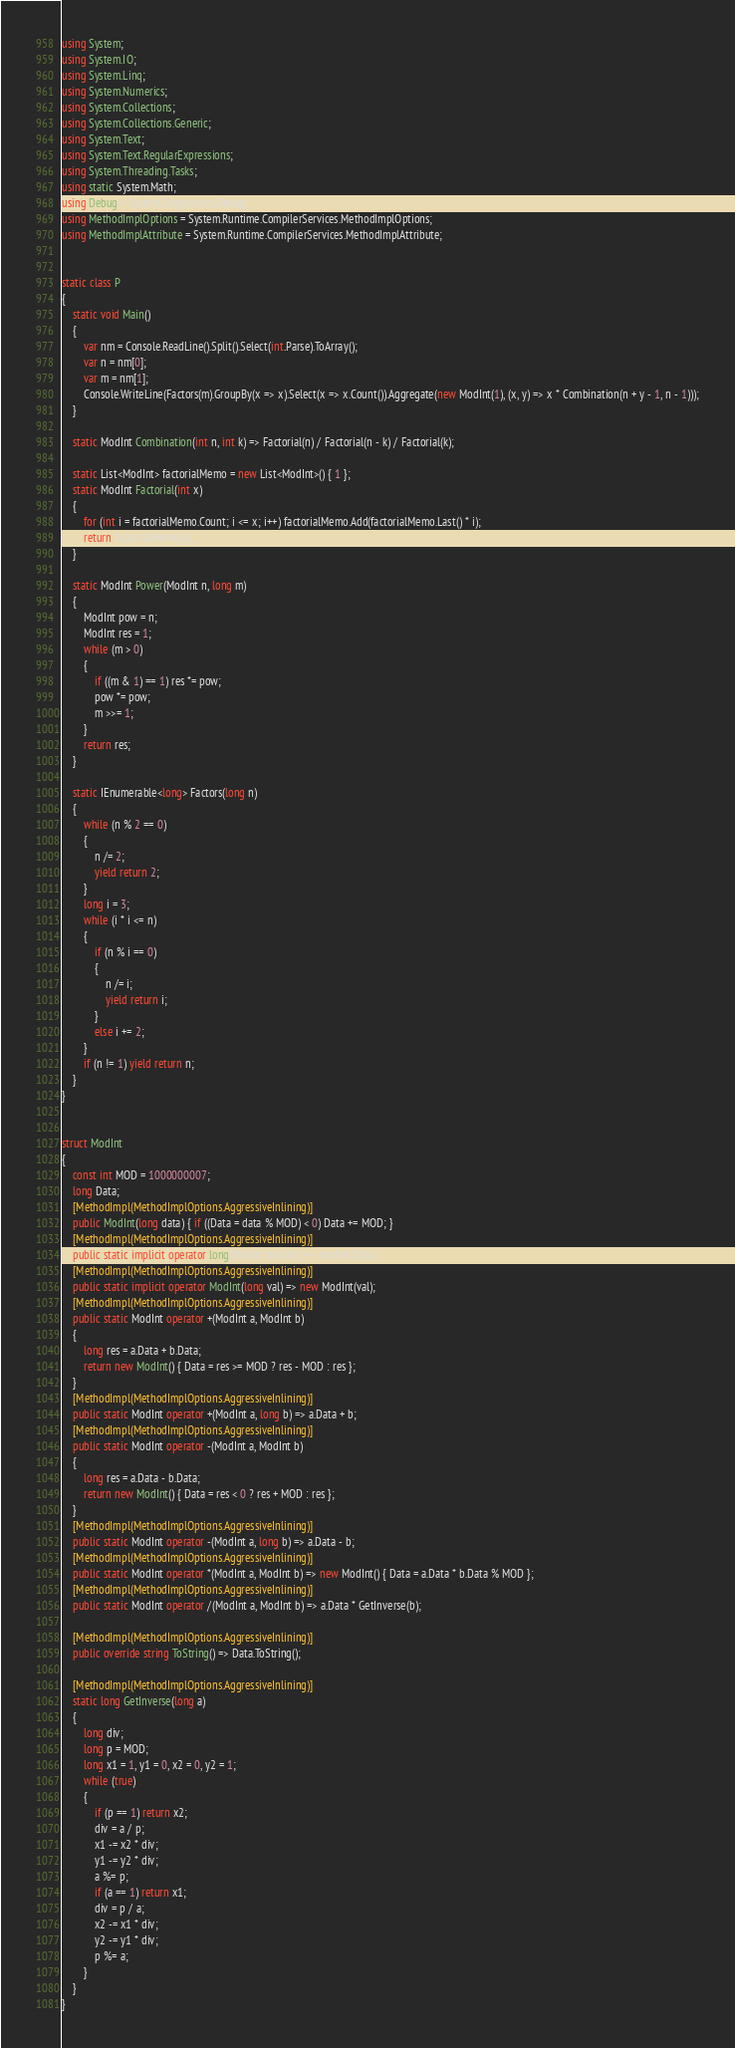<code> <loc_0><loc_0><loc_500><loc_500><_C#_>using System;
using System.IO;
using System.Linq;
using System.Numerics;
using System.Collections;
using System.Collections.Generic;
using System.Text;
using System.Text.RegularExpressions;
using System.Threading.Tasks;
using static System.Math;
using Debug = System.Diagnostics.Debug;
using MethodImplOptions = System.Runtime.CompilerServices.MethodImplOptions;
using MethodImplAttribute = System.Runtime.CompilerServices.MethodImplAttribute;


static class P
{
    static void Main()
    {
        var nm = Console.ReadLine().Split().Select(int.Parse).ToArray();
        var n = nm[0]; 
        var m = nm[1];
        Console.WriteLine(Factors(m).GroupBy(x => x).Select(x => x.Count()).Aggregate(new ModInt(1), (x, y) => x * Combination(n + y - 1, n - 1)));
    }

    static ModInt Combination(int n, int k) => Factorial(n) / Factorial(n - k) / Factorial(k);

    static List<ModInt> factorialMemo = new List<ModInt>() { 1 };
    static ModInt Factorial(int x)
    {
        for (int i = factorialMemo.Count; i <= x; i++) factorialMemo.Add(factorialMemo.Last() * i);
        return factorialMemo[x];
    }

    static ModInt Power(ModInt n, long m)
    {
        ModInt pow = n;
        ModInt res = 1;
        while (m > 0)
        {
            if ((m & 1) == 1) res *= pow;
            pow *= pow;
            m >>= 1;
        }
        return res;
    }

    static IEnumerable<long> Factors(long n)
    {
        while (n % 2 == 0)
        {
            n /= 2;
            yield return 2;
        }
        long i = 3;
        while (i * i <= n)
        {
            if (n % i == 0)
            {
                n /= i;
                yield return i;
            }
            else i += 2;
        }
        if (n != 1) yield return n;
    }
}


struct ModInt
{
    const int MOD = 1000000007;
    long Data;
    [MethodImpl(MethodImplOptions.AggressiveInlining)]
    public ModInt(long data) { if ((Data = data % MOD) < 0) Data += MOD; }
    [MethodImpl(MethodImplOptions.AggressiveInlining)]
    public static implicit operator long(ModInt modInt) => modInt.Data;
    [MethodImpl(MethodImplOptions.AggressiveInlining)]
    public static implicit operator ModInt(long val) => new ModInt(val);
    [MethodImpl(MethodImplOptions.AggressiveInlining)]
    public static ModInt operator +(ModInt a, ModInt b)
    {
        long res = a.Data + b.Data;
        return new ModInt() { Data = res >= MOD ? res - MOD : res };
    }
    [MethodImpl(MethodImplOptions.AggressiveInlining)]
    public static ModInt operator +(ModInt a, long b) => a.Data + b;
    [MethodImpl(MethodImplOptions.AggressiveInlining)]
    public static ModInt operator -(ModInt a, ModInt b)
    {
        long res = a.Data - b.Data;
        return new ModInt() { Data = res < 0 ? res + MOD : res };
    }
    [MethodImpl(MethodImplOptions.AggressiveInlining)]
    public static ModInt operator -(ModInt a, long b) => a.Data - b;
    [MethodImpl(MethodImplOptions.AggressiveInlining)]
    public static ModInt operator *(ModInt a, ModInt b) => new ModInt() { Data = a.Data * b.Data % MOD };
    [MethodImpl(MethodImplOptions.AggressiveInlining)]
    public static ModInt operator /(ModInt a, ModInt b) => a.Data * GetInverse(b);

    [MethodImpl(MethodImplOptions.AggressiveInlining)]
    public override string ToString() => Data.ToString();

    [MethodImpl(MethodImplOptions.AggressiveInlining)]
    static long GetInverse(long a)
    {
        long div;
        long p = MOD;
        long x1 = 1, y1 = 0, x2 = 0, y2 = 1;
        while (true)
        {
            if (p == 1) return x2;
            div = a / p;
            x1 -= x2 * div;
            y1 -= y2 * div;
            a %= p;
            if (a == 1) return x1;
            div = p / a;
            x2 -= x1 * div;
            y2 -= y1 * div;
            p %= a;
        }
    }
}
</code> 